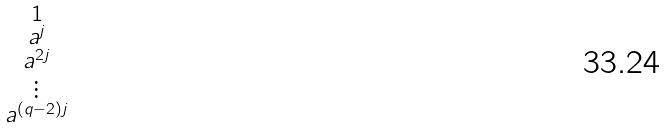Convert formula to latex. <formula><loc_0><loc_0><loc_500><loc_500>\begin{smallmatrix} 1 \\ a ^ { j } \\ a ^ { 2 j } \\ \vdots \\ a ^ { ( q - 2 ) j } \end{smallmatrix}</formula> 